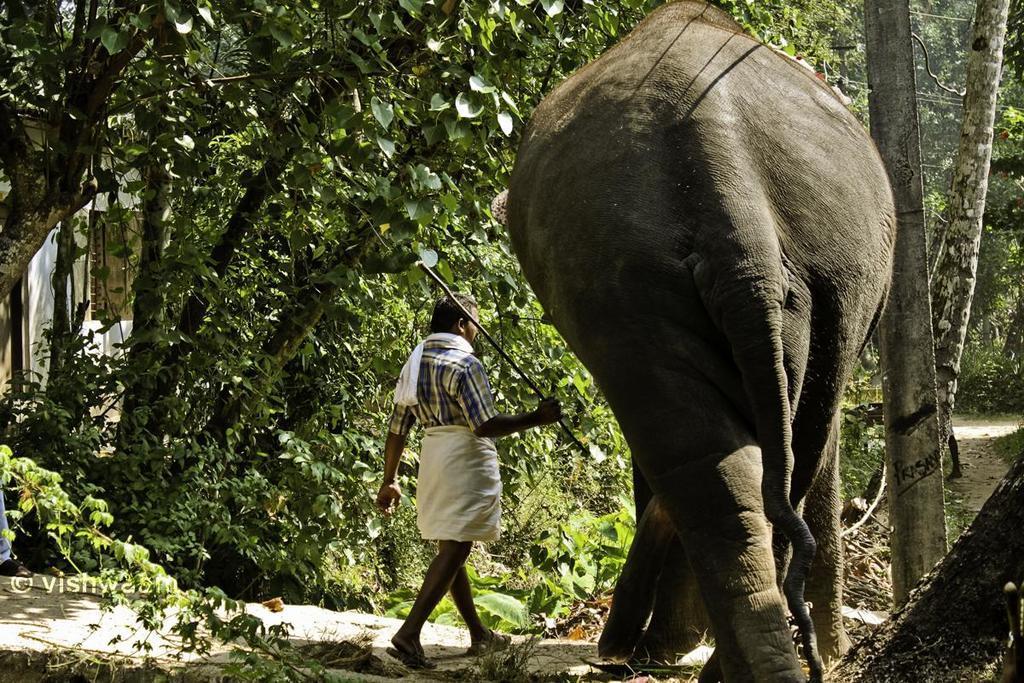Please provide a concise description of this image. This image is taken outdoors. At the bottom of the image there is a ground with grass on it. In the background there are many trees and plants with green leaves, stems and branches. On the right side of the image there is a pole. In the middle of the image there is an elephant on the ground and a man is walking on the ground. He is holding a stick in his hand. 